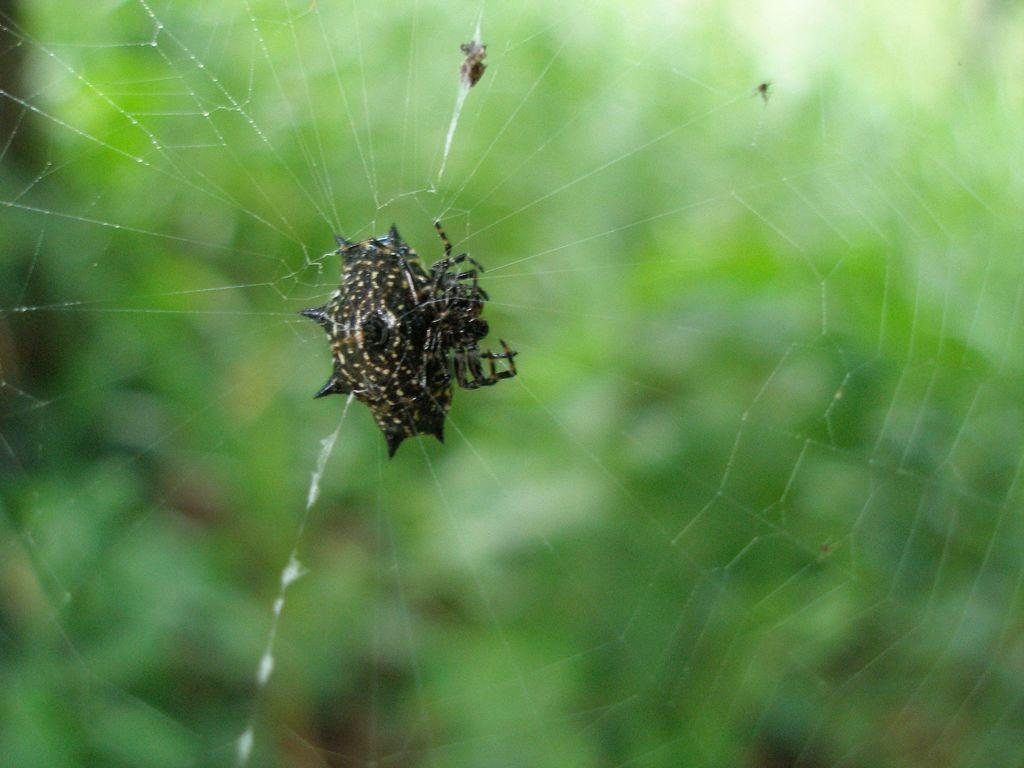What is the main subject in the center of the image? There is an insect in the center of the image. Can you describe the background of the image? The background of the image is blurry. What type of mitten is the giraffe holding with its hoof in the image? There is no giraffe or mitten present in the image; it features an insect. How is the hammer being used in the image? There is no hammer present in the image. 